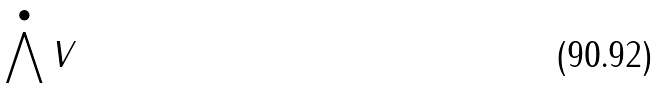Convert formula to latex. <formula><loc_0><loc_0><loc_500><loc_500>\bigwedge ^ { \bullet } V</formula> 